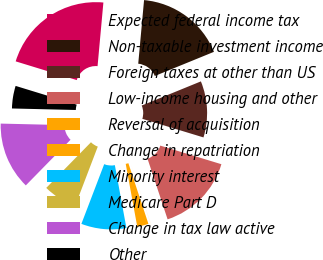Convert chart to OTSL. <chart><loc_0><loc_0><loc_500><loc_500><pie_chart><fcel>Expected federal income tax<fcel>Non-taxable investment income<fcel>Foreign taxes at other than US<fcel>Low-income housing and other<fcel>Reversal of acquisition<fcel>Change in repatriation<fcel>Minority interest<fcel>Medicare Part D<fcel>Change in tax law active<fcel>Other<nl><fcel>21.72%<fcel>17.38%<fcel>10.87%<fcel>15.21%<fcel>0.01%<fcel>2.19%<fcel>8.7%<fcel>6.53%<fcel>13.04%<fcel>4.36%<nl></chart> 